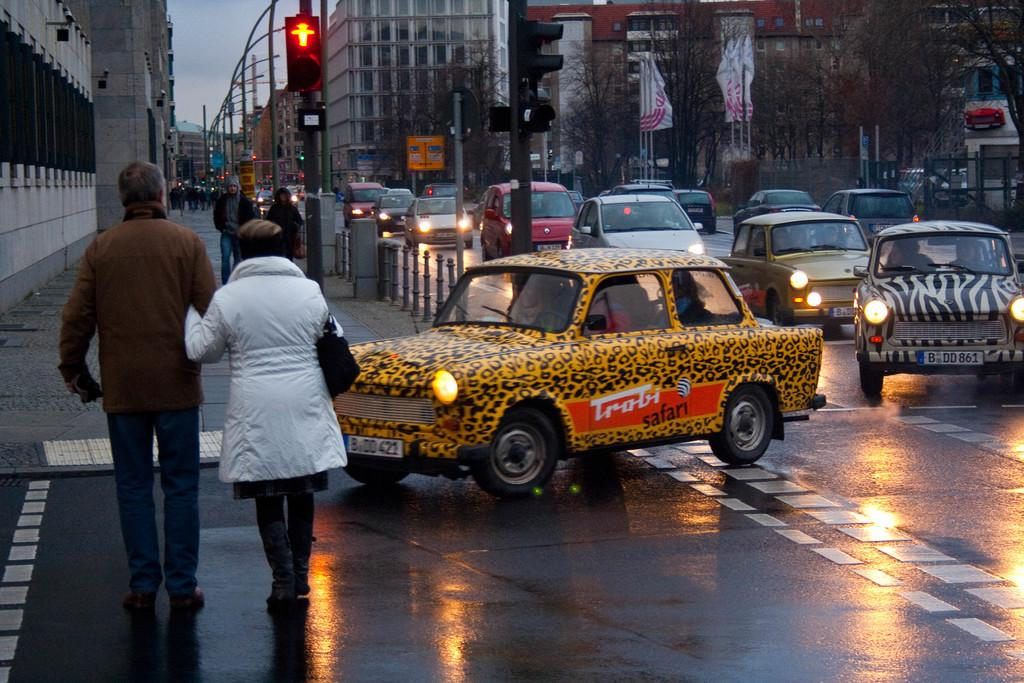<image>
Write a terse but informative summary of the picture. A cheetah print car with Trobi Safari printed on its side. 